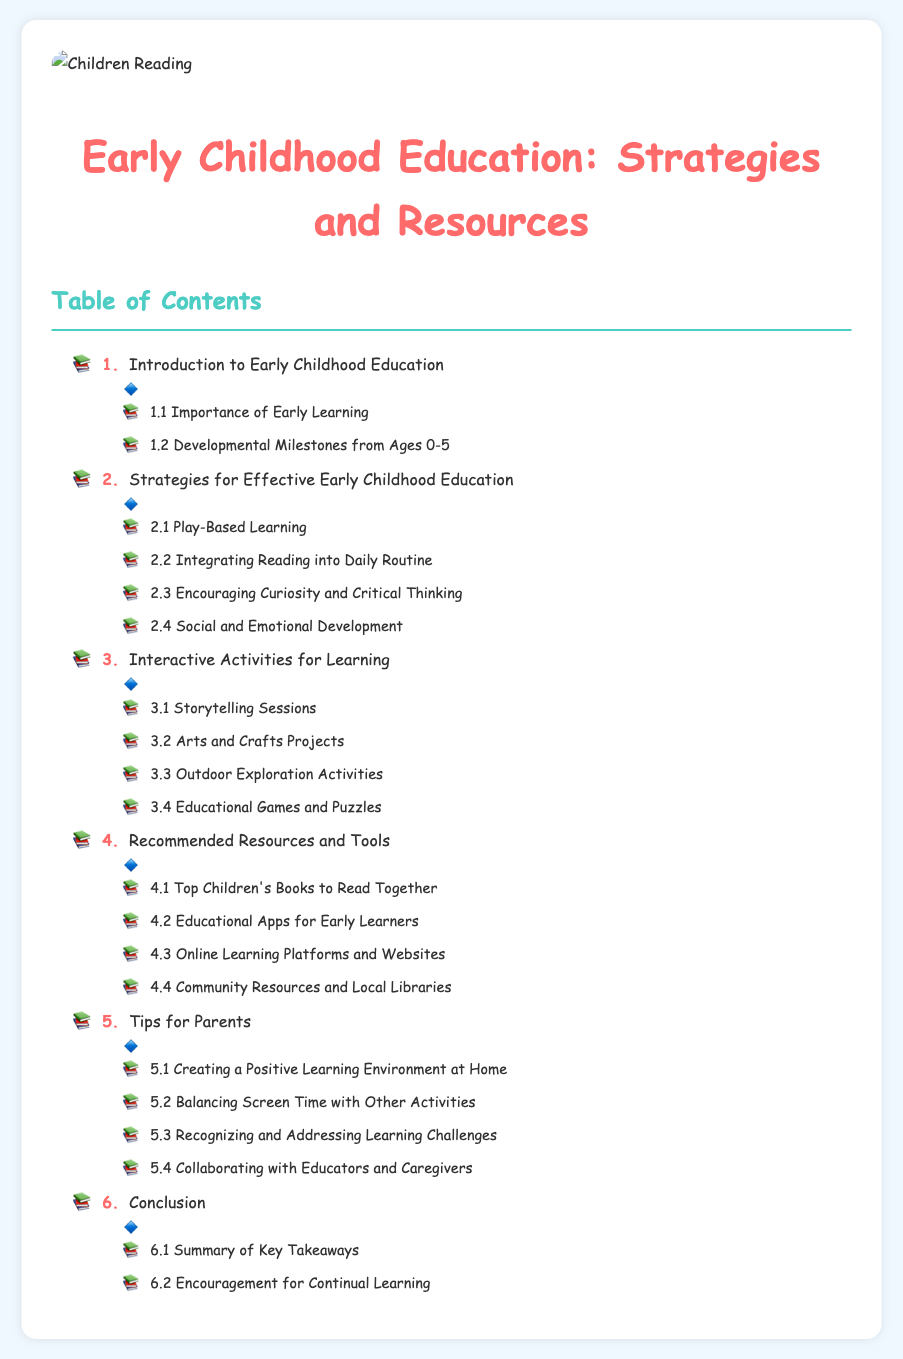What is the first section of the document? The first section listed in the table of contents is "Introduction to Early Childhood Education."
Answer: Introduction to Early Childhood Education How many strategies are listed for effective early childhood education? The document lists four strategies under "Strategies for Effective Early Childhood Education."
Answer: 4 What type of activities are included in the "Interactive Activities for Learning" section? The section includes activities like "Storytelling Sessions," "Arts and Crafts Projects," "Outdoor Exploration Activities," and "Educational Games and Puzzles."
Answer: Storytelling Sessions, Arts and Crafts Projects, Outdoor Exploration Activities, Educational Games and Puzzles What is one recommended resource for parents? One of the resources mentioned is "Top Children's Books to Read Together."
Answer: Top Children's Books to Read Together How many tips for parents are provided in the document? The document provides four tips for parents under the "Tips for Parents" section.
Answer: 4 What is the last section of the table of contents? The last section mentioned is "Conclusion."
Answer: Conclusion Which subsection addresses the importance of early learning? The subsection that addresses this is "1.1 Importance of Early Learning."
Answer: 1.1 Importance of Early Learning What is the objective of the "Conclusion" section? The "Conclusion" section summarizes key takeaways and encourages in continual learning.
Answer: Summary of Key Takeaways, Encouragement for Continual Learning 